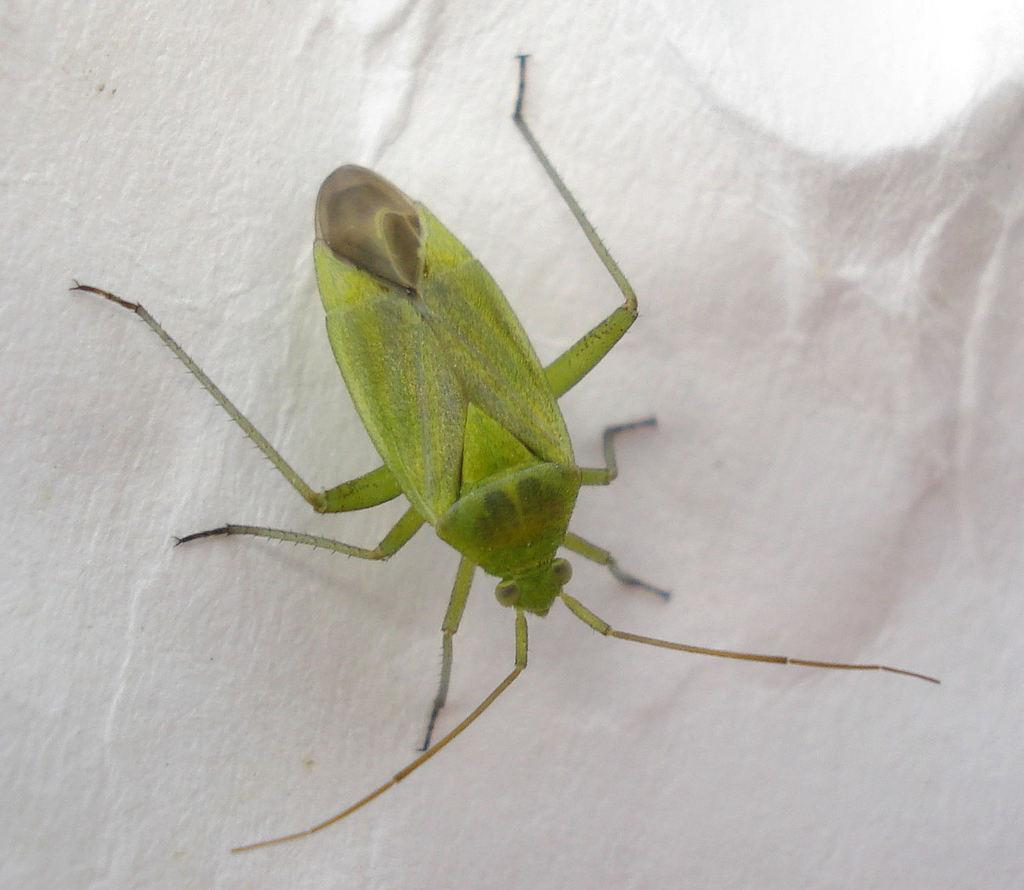What type of insect is in the image? There is a green insect in the image. What color is the surface on which the insect is located? The insect is on a white surface. How does the insect compare to the heat in the image? There is no information about heat in the image, as it only features a green insect on a white surface. 